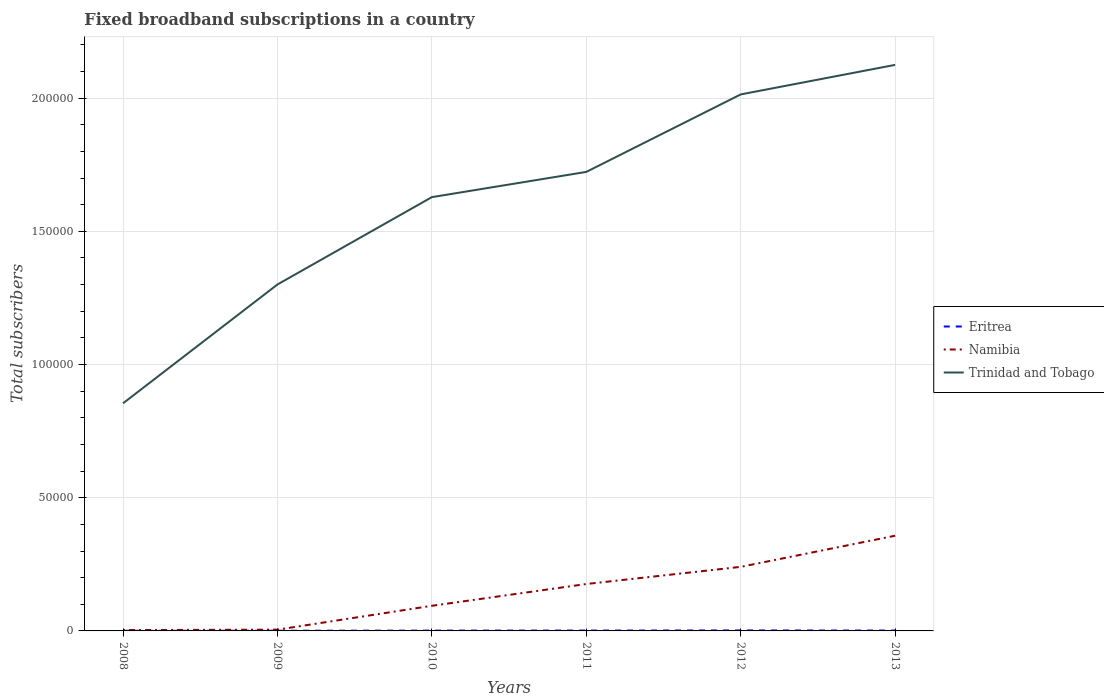How many different coloured lines are there?
Provide a succinct answer. 3. Across all years, what is the maximum number of broadband subscriptions in Trinidad and Tobago?
Provide a succinct answer. 8.54e+04. What is the total number of broadband subscriptions in Eritrea in the graph?
Give a very brief answer. -28. What is the difference between the highest and the second highest number of broadband subscriptions in Namibia?
Your response must be concise. 3.54e+04. What is the difference between the highest and the lowest number of broadband subscriptions in Eritrea?
Your response must be concise. 4. Is the number of broadband subscriptions in Trinidad and Tobago strictly greater than the number of broadband subscriptions in Namibia over the years?
Your response must be concise. No. How many lines are there?
Keep it short and to the point. 3. How many years are there in the graph?
Give a very brief answer. 6. Where does the legend appear in the graph?
Make the answer very short. Center right. How are the legend labels stacked?
Keep it short and to the point. Vertical. What is the title of the graph?
Offer a very short reply. Fixed broadband subscriptions in a country. What is the label or title of the Y-axis?
Your answer should be compact. Total subscribers. What is the Total subscribers of Eritrea in 2008?
Your response must be concise. 44. What is the Total subscribers of Namibia in 2008?
Offer a terse response. 320. What is the Total subscribers of Trinidad and Tobago in 2008?
Provide a short and direct response. 8.54e+04. What is the Total subscribers of Namibia in 2009?
Keep it short and to the point. 477. What is the Total subscribers of Trinidad and Tobago in 2009?
Offer a very short reply. 1.30e+05. What is the Total subscribers in Eritrea in 2010?
Your answer should be compact. 118. What is the Total subscribers of Namibia in 2010?
Keep it short and to the point. 9435. What is the Total subscribers in Trinidad and Tobago in 2010?
Provide a short and direct response. 1.63e+05. What is the Total subscribers of Eritrea in 2011?
Your answer should be compact. 141. What is the Total subscribers in Namibia in 2011?
Your answer should be very brief. 1.76e+04. What is the Total subscribers in Trinidad and Tobago in 2011?
Provide a succinct answer. 1.72e+05. What is the Total subscribers of Eritrea in 2012?
Offer a terse response. 185. What is the Total subscribers in Namibia in 2012?
Offer a terse response. 2.41e+04. What is the Total subscribers of Trinidad and Tobago in 2012?
Provide a short and direct response. 2.01e+05. What is the Total subscribers in Eritrea in 2013?
Give a very brief answer. 146. What is the Total subscribers in Namibia in 2013?
Provide a short and direct response. 3.57e+04. What is the Total subscribers in Trinidad and Tobago in 2013?
Your answer should be compact. 2.12e+05. Across all years, what is the maximum Total subscribers of Eritrea?
Your answer should be very brief. 185. Across all years, what is the maximum Total subscribers in Namibia?
Your answer should be very brief. 3.57e+04. Across all years, what is the maximum Total subscribers in Trinidad and Tobago?
Make the answer very short. 2.12e+05. Across all years, what is the minimum Total subscribers of Eritrea?
Ensure brevity in your answer.  44. Across all years, what is the minimum Total subscribers in Namibia?
Your answer should be very brief. 320. Across all years, what is the minimum Total subscribers of Trinidad and Tobago?
Make the answer very short. 8.54e+04. What is the total Total subscribers in Eritrea in the graph?
Give a very brief answer. 704. What is the total Total subscribers of Namibia in the graph?
Provide a short and direct response. 8.76e+04. What is the total Total subscribers in Trinidad and Tobago in the graph?
Provide a short and direct response. 9.65e+05. What is the difference between the Total subscribers in Eritrea in 2008 and that in 2009?
Ensure brevity in your answer.  -26. What is the difference between the Total subscribers in Namibia in 2008 and that in 2009?
Give a very brief answer. -157. What is the difference between the Total subscribers of Trinidad and Tobago in 2008 and that in 2009?
Offer a terse response. -4.46e+04. What is the difference between the Total subscribers in Eritrea in 2008 and that in 2010?
Provide a succinct answer. -74. What is the difference between the Total subscribers in Namibia in 2008 and that in 2010?
Keep it short and to the point. -9115. What is the difference between the Total subscribers of Trinidad and Tobago in 2008 and that in 2010?
Give a very brief answer. -7.74e+04. What is the difference between the Total subscribers in Eritrea in 2008 and that in 2011?
Provide a succinct answer. -97. What is the difference between the Total subscribers of Namibia in 2008 and that in 2011?
Give a very brief answer. -1.73e+04. What is the difference between the Total subscribers in Trinidad and Tobago in 2008 and that in 2011?
Provide a short and direct response. -8.69e+04. What is the difference between the Total subscribers in Eritrea in 2008 and that in 2012?
Your response must be concise. -141. What is the difference between the Total subscribers in Namibia in 2008 and that in 2012?
Offer a terse response. -2.37e+04. What is the difference between the Total subscribers of Trinidad and Tobago in 2008 and that in 2012?
Offer a very short reply. -1.16e+05. What is the difference between the Total subscribers of Eritrea in 2008 and that in 2013?
Ensure brevity in your answer.  -102. What is the difference between the Total subscribers in Namibia in 2008 and that in 2013?
Make the answer very short. -3.54e+04. What is the difference between the Total subscribers in Trinidad and Tobago in 2008 and that in 2013?
Offer a very short reply. -1.27e+05. What is the difference between the Total subscribers of Eritrea in 2009 and that in 2010?
Keep it short and to the point. -48. What is the difference between the Total subscribers of Namibia in 2009 and that in 2010?
Offer a terse response. -8958. What is the difference between the Total subscribers of Trinidad and Tobago in 2009 and that in 2010?
Give a very brief answer. -3.28e+04. What is the difference between the Total subscribers in Eritrea in 2009 and that in 2011?
Your response must be concise. -71. What is the difference between the Total subscribers of Namibia in 2009 and that in 2011?
Give a very brief answer. -1.71e+04. What is the difference between the Total subscribers in Trinidad and Tobago in 2009 and that in 2011?
Your response must be concise. -4.23e+04. What is the difference between the Total subscribers in Eritrea in 2009 and that in 2012?
Offer a terse response. -115. What is the difference between the Total subscribers of Namibia in 2009 and that in 2012?
Make the answer very short. -2.36e+04. What is the difference between the Total subscribers in Trinidad and Tobago in 2009 and that in 2012?
Your answer should be very brief. -7.14e+04. What is the difference between the Total subscribers in Eritrea in 2009 and that in 2013?
Provide a short and direct response. -76. What is the difference between the Total subscribers in Namibia in 2009 and that in 2013?
Offer a very short reply. -3.53e+04. What is the difference between the Total subscribers in Trinidad and Tobago in 2009 and that in 2013?
Ensure brevity in your answer.  -8.24e+04. What is the difference between the Total subscribers of Eritrea in 2010 and that in 2011?
Offer a very short reply. -23. What is the difference between the Total subscribers of Namibia in 2010 and that in 2011?
Make the answer very short. -8175. What is the difference between the Total subscribers in Trinidad and Tobago in 2010 and that in 2011?
Keep it short and to the point. -9468. What is the difference between the Total subscribers in Eritrea in 2010 and that in 2012?
Provide a short and direct response. -67. What is the difference between the Total subscribers of Namibia in 2010 and that in 2012?
Offer a very short reply. -1.46e+04. What is the difference between the Total subscribers of Trinidad and Tobago in 2010 and that in 2012?
Your response must be concise. -3.86e+04. What is the difference between the Total subscribers in Eritrea in 2010 and that in 2013?
Your response must be concise. -28. What is the difference between the Total subscribers in Namibia in 2010 and that in 2013?
Your answer should be very brief. -2.63e+04. What is the difference between the Total subscribers in Trinidad and Tobago in 2010 and that in 2013?
Give a very brief answer. -4.96e+04. What is the difference between the Total subscribers of Eritrea in 2011 and that in 2012?
Your response must be concise. -44. What is the difference between the Total subscribers in Namibia in 2011 and that in 2012?
Your answer should be very brief. -6443. What is the difference between the Total subscribers of Trinidad and Tobago in 2011 and that in 2012?
Keep it short and to the point. -2.91e+04. What is the difference between the Total subscribers in Eritrea in 2011 and that in 2013?
Offer a very short reply. -5. What is the difference between the Total subscribers in Namibia in 2011 and that in 2013?
Make the answer very short. -1.81e+04. What is the difference between the Total subscribers of Trinidad and Tobago in 2011 and that in 2013?
Your answer should be very brief. -4.02e+04. What is the difference between the Total subscribers in Eritrea in 2012 and that in 2013?
Ensure brevity in your answer.  39. What is the difference between the Total subscribers of Namibia in 2012 and that in 2013?
Keep it short and to the point. -1.17e+04. What is the difference between the Total subscribers in Trinidad and Tobago in 2012 and that in 2013?
Your response must be concise. -1.11e+04. What is the difference between the Total subscribers in Eritrea in 2008 and the Total subscribers in Namibia in 2009?
Provide a short and direct response. -433. What is the difference between the Total subscribers in Eritrea in 2008 and the Total subscribers in Trinidad and Tobago in 2009?
Offer a very short reply. -1.30e+05. What is the difference between the Total subscribers of Namibia in 2008 and the Total subscribers of Trinidad and Tobago in 2009?
Make the answer very short. -1.30e+05. What is the difference between the Total subscribers of Eritrea in 2008 and the Total subscribers of Namibia in 2010?
Your answer should be very brief. -9391. What is the difference between the Total subscribers of Eritrea in 2008 and the Total subscribers of Trinidad and Tobago in 2010?
Provide a succinct answer. -1.63e+05. What is the difference between the Total subscribers of Namibia in 2008 and the Total subscribers of Trinidad and Tobago in 2010?
Offer a very short reply. -1.63e+05. What is the difference between the Total subscribers in Eritrea in 2008 and the Total subscribers in Namibia in 2011?
Your answer should be very brief. -1.76e+04. What is the difference between the Total subscribers of Eritrea in 2008 and the Total subscribers of Trinidad and Tobago in 2011?
Make the answer very short. -1.72e+05. What is the difference between the Total subscribers of Namibia in 2008 and the Total subscribers of Trinidad and Tobago in 2011?
Offer a very short reply. -1.72e+05. What is the difference between the Total subscribers in Eritrea in 2008 and the Total subscribers in Namibia in 2012?
Make the answer very short. -2.40e+04. What is the difference between the Total subscribers in Eritrea in 2008 and the Total subscribers in Trinidad and Tobago in 2012?
Keep it short and to the point. -2.01e+05. What is the difference between the Total subscribers of Namibia in 2008 and the Total subscribers of Trinidad and Tobago in 2012?
Ensure brevity in your answer.  -2.01e+05. What is the difference between the Total subscribers of Eritrea in 2008 and the Total subscribers of Namibia in 2013?
Provide a short and direct response. -3.57e+04. What is the difference between the Total subscribers of Eritrea in 2008 and the Total subscribers of Trinidad and Tobago in 2013?
Make the answer very short. -2.12e+05. What is the difference between the Total subscribers in Namibia in 2008 and the Total subscribers in Trinidad and Tobago in 2013?
Ensure brevity in your answer.  -2.12e+05. What is the difference between the Total subscribers in Eritrea in 2009 and the Total subscribers in Namibia in 2010?
Give a very brief answer. -9365. What is the difference between the Total subscribers in Eritrea in 2009 and the Total subscribers in Trinidad and Tobago in 2010?
Provide a short and direct response. -1.63e+05. What is the difference between the Total subscribers in Namibia in 2009 and the Total subscribers in Trinidad and Tobago in 2010?
Provide a succinct answer. -1.62e+05. What is the difference between the Total subscribers in Eritrea in 2009 and the Total subscribers in Namibia in 2011?
Give a very brief answer. -1.75e+04. What is the difference between the Total subscribers of Eritrea in 2009 and the Total subscribers of Trinidad and Tobago in 2011?
Your response must be concise. -1.72e+05. What is the difference between the Total subscribers in Namibia in 2009 and the Total subscribers in Trinidad and Tobago in 2011?
Provide a short and direct response. -1.72e+05. What is the difference between the Total subscribers in Eritrea in 2009 and the Total subscribers in Namibia in 2012?
Your answer should be very brief. -2.40e+04. What is the difference between the Total subscribers in Eritrea in 2009 and the Total subscribers in Trinidad and Tobago in 2012?
Offer a terse response. -2.01e+05. What is the difference between the Total subscribers in Namibia in 2009 and the Total subscribers in Trinidad and Tobago in 2012?
Keep it short and to the point. -2.01e+05. What is the difference between the Total subscribers of Eritrea in 2009 and the Total subscribers of Namibia in 2013?
Ensure brevity in your answer.  -3.57e+04. What is the difference between the Total subscribers of Eritrea in 2009 and the Total subscribers of Trinidad and Tobago in 2013?
Offer a terse response. -2.12e+05. What is the difference between the Total subscribers in Namibia in 2009 and the Total subscribers in Trinidad and Tobago in 2013?
Ensure brevity in your answer.  -2.12e+05. What is the difference between the Total subscribers in Eritrea in 2010 and the Total subscribers in Namibia in 2011?
Give a very brief answer. -1.75e+04. What is the difference between the Total subscribers in Eritrea in 2010 and the Total subscribers in Trinidad and Tobago in 2011?
Ensure brevity in your answer.  -1.72e+05. What is the difference between the Total subscribers in Namibia in 2010 and the Total subscribers in Trinidad and Tobago in 2011?
Your response must be concise. -1.63e+05. What is the difference between the Total subscribers in Eritrea in 2010 and the Total subscribers in Namibia in 2012?
Your answer should be compact. -2.39e+04. What is the difference between the Total subscribers in Eritrea in 2010 and the Total subscribers in Trinidad and Tobago in 2012?
Offer a very short reply. -2.01e+05. What is the difference between the Total subscribers of Namibia in 2010 and the Total subscribers of Trinidad and Tobago in 2012?
Your response must be concise. -1.92e+05. What is the difference between the Total subscribers in Eritrea in 2010 and the Total subscribers in Namibia in 2013?
Offer a very short reply. -3.56e+04. What is the difference between the Total subscribers of Eritrea in 2010 and the Total subscribers of Trinidad and Tobago in 2013?
Provide a succinct answer. -2.12e+05. What is the difference between the Total subscribers in Namibia in 2010 and the Total subscribers in Trinidad and Tobago in 2013?
Give a very brief answer. -2.03e+05. What is the difference between the Total subscribers in Eritrea in 2011 and the Total subscribers in Namibia in 2012?
Ensure brevity in your answer.  -2.39e+04. What is the difference between the Total subscribers in Eritrea in 2011 and the Total subscribers in Trinidad and Tobago in 2012?
Your response must be concise. -2.01e+05. What is the difference between the Total subscribers in Namibia in 2011 and the Total subscribers in Trinidad and Tobago in 2012?
Ensure brevity in your answer.  -1.84e+05. What is the difference between the Total subscribers in Eritrea in 2011 and the Total subscribers in Namibia in 2013?
Give a very brief answer. -3.56e+04. What is the difference between the Total subscribers in Eritrea in 2011 and the Total subscribers in Trinidad and Tobago in 2013?
Keep it short and to the point. -2.12e+05. What is the difference between the Total subscribers of Namibia in 2011 and the Total subscribers of Trinidad and Tobago in 2013?
Your answer should be compact. -1.95e+05. What is the difference between the Total subscribers of Eritrea in 2012 and the Total subscribers of Namibia in 2013?
Make the answer very short. -3.56e+04. What is the difference between the Total subscribers in Eritrea in 2012 and the Total subscribers in Trinidad and Tobago in 2013?
Your answer should be compact. -2.12e+05. What is the difference between the Total subscribers of Namibia in 2012 and the Total subscribers of Trinidad and Tobago in 2013?
Your response must be concise. -1.88e+05. What is the average Total subscribers in Eritrea per year?
Your answer should be compact. 117.33. What is the average Total subscribers of Namibia per year?
Your answer should be compact. 1.46e+04. What is the average Total subscribers of Trinidad and Tobago per year?
Ensure brevity in your answer.  1.61e+05. In the year 2008, what is the difference between the Total subscribers in Eritrea and Total subscribers in Namibia?
Your answer should be very brief. -276. In the year 2008, what is the difference between the Total subscribers of Eritrea and Total subscribers of Trinidad and Tobago?
Ensure brevity in your answer.  -8.54e+04. In the year 2008, what is the difference between the Total subscribers of Namibia and Total subscribers of Trinidad and Tobago?
Your answer should be very brief. -8.51e+04. In the year 2009, what is the difference between the Total subscribers in Eritrea and Total subscribers in Namibia?
Provide a short and direct response. -407. In the year 2009, what is the difference between the Total subscribers of Eritrea and Total subscribers of Trinidad and Tobago?
Give a very brief answer. -1.30e+05. In the year 2009, what is the difference between the Total subscribers of Namibia and Total subscribers of Trinidad and Tobago?
Your answer should be compact. -1.30e+05. In the year 2010, what is the difference between the Total subscribers of Eritrea and Total subscribers of Namibia?
Ensure brevity in your answer.  -9317. In the year 2010, what is the difference between the Total subscribers of Eritrea and Total subscribers of Trinidad and Tobago?
Keep it short and to the point. -1.63e+05. In the year 2010, what is the difference between the Total subscribers in Namibia and Total subscribers in Trinidad and Tobago?
Your answer should be compact. -1.53e+05. In the year 2011, what is the difference between the Total subscribers of Eritrea and Total subscribers of Namibia?
Your answer should be very brief. -1.75e+04. In the year 2011, what is the difference between the Total subscribers of Eritrea and Total subscribers of Trinidad and Tobago?
Your answer should be very brief. -1.72e+05. In the year 2011, what is the difference between the Total subscribers of Namibia and Total subscribers of Trinidad and Tobago?
Offer a very short reply. -1.55e+05. In the year 2012, what is the difference between the Total subscribers in Eritrea and Total subscribers in Namibia?
Provide a short and direct response. -2.39e+04. In the year 2012, what is the difference between the Total subscribers in Eritrea and Total subscribers in Trinidad and Tobago?
Provide a succinct answer. -2.01e+05. In the year 2012, what is the difference between the Total subscribers in Namibia and Total subscribers in Trinidad and Tobago?
Offer a terse response. -1.77e+05. In the year 2013, what is the difference between the Total subscribers of Eritrea and Total subscribers of Namibia?
Offer a very short reply. -3.56e+04. In the year 2013, what is the difference between the Total subscribers in Eritrea and Total subscribers in Trinidad and Tobago?
Offer a very short reply. -2.12e+05. In the year 2013, what is the difference between the Total subscribers in Namibia and Total subscribers in Trinidad and Tobago?
Your answer should be compact. -1.77e+05. What is the ratio of the Total subscribers in Eritrea in 2008 to that in 2009?
Your answer should be compact. 0.63. What is the ratio of the Total subscribers of Namibia in 2008 to that in 2009?
Your response must be concise. 0.67. What is the ratio of the Total subscribers of Trinidad and Tobago in 2008 to that in 2009?
Give a very brief answer. 0.66. What is the ratio of the Total subscribers of Eritrea in 2008 to that in 2010?
Make the answer very short. 0.37. What is the ratio of the Total subscribers of Namibia in 2008 to that in 2010?
Make the answer very short. 0.03. What is the ratio of the Total subscribers in Trinidad and Tobago in 2008 to that in 2010?
Ensure brevity in your answer.  0.52. What is the ratio of the Total subscribers in Eritrea in 2008 to that in 2011?
Provide a short and direct response. 0.31. What is the ratio of the Total subscribers in Namibia in 2008 to that in 2011?
Ensure brevity in your answer.  0.02. What is the ratio of the Total subscribers in Trinidad and Tobago in 2008 to that in 2011?
Keep it short and to the point. 0.5. What is the ratio of the Total subscribers of Eritrea in 2008 to that in 2012?
Your answer should be very brief. 0.24. What is the ratio of the Total subscribers of Namibia in 2008 to that in 2012?
Keep it short and to the point. 0.01. What is the ratio of the Total subscribers of Trinidad and Tobago in 2008 to that in 2012?
Provide a succinct answer. 0.42. What is the ratio of the Total subscribers in Eritrea in 2008 to that in 2013?
Your answer should be compact. 0.3. What is the ratio of the Total subscribers in Namibia in 2008 to that in 2013?
Your answer should be compact. 0.01. What is the ratio of the Total subscribers of Trinidad and Tobago in 2008 to that in 2013?
Your answer should be very brief. 0.4. What is the ratio of the Total subscribers of Eritrea in 2009 to that in 2010?
Your response must be concise. 0.59. What is the ratio of the Total subscribers in Namibia in 2009 to that in 2010?
Offer a terse response. 0.05. What is the ratio of the Total subscribers in Trinidad and Tobago in 2009 to that in 2010?
Give a very brief answer. 0.8. What is the ratio of the Total subscribers in Eritrea in 2009 to that in 2011?
Offer a very short reply. 0.5. What is the ratio of the Total subscribers in Namibia in 2009 to that in 2011?
Make the answer very short. 0.03. What is the ratio of the Total subscribers of Trinidad and Tobago in 2009 to that in 2011?
Make the answer very short. 0.75. What is the ratio of the Total subscribers in Eritrea in 2009 to that in 2012?
Offer a very short reply. 0.38. What is the ratio of the Total subscribers of Namibia in 2009 to that in 2012?
Your response must be concise. 0.02. What is the ratio of the Total subscribers in Trinidad and Tobago in 2009 to that in 2012?
Keep it short and to the point. 0.65. What is the ratio of the Total subscribers of Eritrea in 2009 to that in 2013?
Provide a succinct answer. 0.48. What is the ratio of the Total subscribers in Namibia in 2009 to that in 2013?
Make the answer very short. 0.01. What is the ratio of the Total subscribers in Trinidad and Tobago in 2009 to that in 2013?
Your answer should be very brief. 0.61. What is the ratio of the Total subscribers of Eritrea in 2010 to that in 2011?
Provide a short and direct response. 0.84. What is the ratio of the Total subscribers in Namibia in 2010 to that in 2011?
Offer a very short reply. 0.54. What is the ratio of the Total subscribers in Trinidad and Tobago in 2010 to that in 2011?
Your answer should be very brief. 0.95. What is the ratio of the Total subscribers in Eritrea in 2010 to that in 2012?
Offer a very short reply. 0.64. What is the ratio of the Total subscribers in Namibia in 2010 to that in 2012?
Give a very brief answer. 0.39. What is the ratio of the Total subscribers in Trinidad and Tobago in 2010 to that in 2012?
Ensure brevity in your answer.  0.81. What is the ratio of the Total subscribers in Eritrea in 2010 to that in 2013?
Your answer should be very brief. 0.81. What is the ratio of the Total subscribers of Namibia in 2010 to that in 2013?
Ensure brevity in your answer.  0.26. What is the ratio of the Total subscribers of Trinidad and Tobago in 2010 to that in 2013?
Your answer should be compact. 0.77. What is the ratio of the Total subscribers in Eritrea in 2011 to that in 2012?
Make the answer very short. 0.76. What is the ratio of the Total subscribers of Namibia in 2011 to that in 2012?
Your response must be concise. 0.73. What is the ratio of the Total subscribers of Trinidad and Tobago in 2011 to that in 2012?
Your response must be concise. 0.86. What is the ratio of the Total subscribers in Eritrea in 2011 to that in 2013?
Give a very brief answer. 0.97. What is the ratio of the Total subscribers in Namibia in 2011 to that in 2013?
Ensure brevity in your answer.  0.49. What is the ratio of the Total subscribers of Trinidad and Tobago in 2011 to that in 2013?
Your response must be concise. 0.81. What is the ratio of the Total subscribers of Eritrea in 2012 to that in 2013?
Offer a terse response. 1.27. What is the ratio of the Total subscribers in Namibia in 2012 to that in 2013?
Give a very brief answer. 0.67. What is the ratio of the Total subscribers of Trinidad and Tobago in 2012 to that in 2013?
Offer a terse response. 0.95. What is the difference between the highest and the second highest Total subscribers in Eritrea?
Make the answer very short. 39. What is the difference between the highest and the second highest Total subscribers in Namibia?
Keep it short and to the point. 1.17e+04. What is the difference between the highest and the second highest Total subscribers of Trinidad and Tobago?
Keep it short and to the point. 1.11e+04. What is the difference between the highest and the lowest Total subscribers in Eritrea?
Offer a very short reply. 141. What is the difference between the highest and the lowest Total subscribers in Namibia?
Offer a terse response. 3.54e+04. What is the difference between the highest and the lowest Total subscribers in Trinidad and Tobago?
Provide a succinct answer. 1.27e+05. 